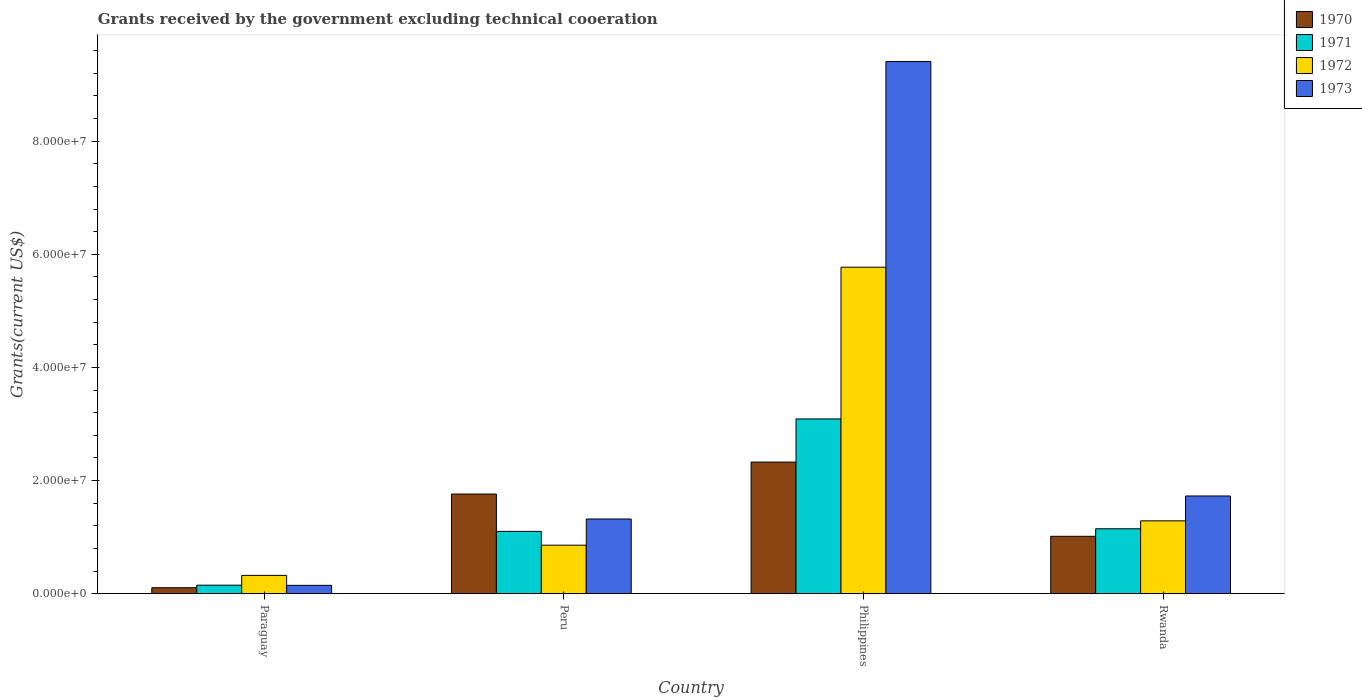Are the number of bars per tick equal to the number of legend labels?
Provide a short and direct response. Yes. How many bars are there on the 2nd tick from the left?
Provide a short and direct response. 4. How many bars are there on the 2nd tick from the right?
Make the answer very short. 4. What is the label of the 3rd group of bars from the left?
Your answer should be very brief. Philippines. In how many cases, is the number of bars for a given country not equal to the number of legend labels?
Provide a succinct answer. 0. What is the total grants received by the government in 1973 in Peru?
Give a very brief answer. 1.32e+07. Across all countries, what is the maximum total grants received by the government in 1972?
Offer a very short reply. 5.77e+07. Across all countries, what is the minimum total grants received by the government in 1973?
Offer a very short reply. 1.47e+06. In which country was the total grants received by the government in 1971 minimum?
Give a very brief answer. Paraguay. What is the total total grants received by the government in 1973 in the graph?
Make the answer very short. 1.26e+08. What is the difference between the total grants received by the government in 1972 in Paraguay and that in Philippines?
Your answer should be very brief. -5.45e+07. What is the difference between the total grants received by the government in 1973 in Philippines and the total grants received by the government in 1971 in Paraguay?
Your response must be concise. 9.26e+07. What is the average total grants received by the government in 1972 per country?
Offer a terse response. 2.06e+07. What is the difference between the total grants received by the government of/in 1973 and total grants received by the government of/in 1972 in Peru?
Your response must be concise. 4.63e+06. What is the ratio of the total grants received by the government in 1973 in Paraguay to that in Peru?
Make the answer very short. 0.11. Is the difference between the total grants received by the government in 1973 in Philippines and Rwanda greater than the difference between the total grants received by the government in 1972 in Philippines and Rwanda?
Make the answer very short. Yes. What is the difference between the highest and the second highest total grants received by the government in 1970?
Provide a short and direct response. 5.65e+06. What is the difference between the highest and the lowest total grants received by the government in 1971?
Ensure brevity in your answer.  2.94e+07. What does the 2nd bar from the left in Paraguay represents?
Your answer should be very brief. 1971. Are all the bars in the graph horizontal?
Provide a succinct answer. No. How many countries are there in the graph?
Make the answer very short. 4. Does the graph contain any zero values?
Make the answer very short. No. Does the graph contain grids?
Offer a terse response. No. How many legend labels are there?
Provide a short and direct response. 4. What is the title of the graph?
Provide a succinct answer. Grants received by the government excluding technical cooeration. Does "1999" appear as one of the legend labels in the graph?
Give a very brief answer. No. What is the label or title of the X-axis?
Your answer should be compact. Country. What is the label or title of the Y-axis?
Your answer should be compact. Grants(current US$). What is the Grants(current US$) of 1970 in Paraguay?
Provide a succinct answer. 1.05e+06. What is the Grants(current US$) of 1971 in Paraguay?
Ensure brevity in your answer.  1.50e+06. What is the Grants(current US$) in 1972 in Paraguay?
Keep it short and to the point. 3.23e+06. What is the Grants(current US$) of 1973 in Paraguay?
Provide a succinct answer. 1.47e+06. What is the Grants(current US$) of 1970 in Peru?
Make the answer very short. 1.76e+07. What is the Grants(current US$) of 1971 in Peru?
Offer a terse response. 1.10e+07. What is the Grants(current US$) in 1972 in Peru?
Your answer should be compact. 8.57e+06. What is the Grants(current US$) in 1973 in Peru?
Keep it short and to the point. 1.32e+07. What is the Grants(current US$) in 1970 in Philippines?
Give a very brief answer. 2.33e+07. What is the Grants(current US$) of 1971 in Philippines?
Offer a terse response. 3.09e+07. What is the Grants(current US$) in 1972 in Philippines?
Your response must be concise. 5.77e+07. What is the Grants(current US$) of 1973 in Philippines?
Offer a terse response. 9.41e+07. What is the Grants(current US$) in 1970 in Rwanda?
Your answer should be compact. 1.01e+07. What is the Grants(current US$) in 1971 in Rwanda?
Ensure brevity in your answer.  1.15e+07. What is the Grants(current US$) of 1972 in Rwanda?
Make the answer very short. 1.29e+07. What is the Grants(current US$) in 1973 in Rwanda?
Offer a terse response. 1.73e+07. Across all countries, what is the maximum Grants(current US$) of 1970?
Provide a succinct answer. 2.33e+07. Across all countries, what is the maximum Grants(current US$) in 1971?
Keep it short and to the point. 3.09e+07. Across all countries, what is the maximum Grants(current US$) of 1972?
Keep it short and to the point. 5.77e+07. Across all countries, what is the maximum Grants(current US$) of 1973?
Ensure brevity in your answer.  9.41e+07. Across all countries, what is the minimum Grants(current US$) of 1970?
Offer a very short reply. 1.05e+06. Across all countries, what is the minimum Grants(current US$) of 1971?
Give a very brief answer. 1.50e+06. Across all countries, what is the minimum Grants(current US$) of 1972?
Give a very brief answer. 3.23e+06. Across all countries, what is the minimum Grants(current US$) in 1973?
Make the answer very short. 1.47e+06. What is the total Grants(current US$) of 1970 in the graph?
Make the answer very short. 5.21e+07. What is the total Grants(current US$) of 1971 in the graph?
Your response must be concise. 5.49e+07. What is the total Grants(current US$) of 1972 in the graph?
Ensure brevity in your answer.  8.24e+07. What is the total Grants(current US$) of 1973 in the graph?
Your answer should be very brief. 1.26e+08. What is the difference between the Grants(current US$) in 1970 in Paraguay and that in Peru?
Your answer should be very brief. -1.66e+07. What is the difference between the Grants(current US$) of 1971 in Paraguay and that in Peru?
Keep it short and to the point. -9.51e+06. What is the difference between the Grants(current US$) of 1972 in Paraguay and that in Peru?
Your answer should be very brief. -5.34e+06. What is the difference between the Grants(current US$) in 1973 in Paraguay and that in Peru?
Provide a short and direct response. -1.17e+07. What is the difference between the Grants(current US$) in 1970 in Paraguay and that in Philippines?
Your answer should be compact. -2.22e+07. What is the difference between the Grants(current US$) of 1971 in Paraguay and that in Philippines?
Your answer should be compact. -2.94e+07. What is the difference between the Grants(current US$) of 1972 in Paraguay and that in Philippines?
Offer a very short reply. -5.45e+07. What is the difference between the Grants(current US$) in 1973 in Paraguay and that in Philippines?
Make the answer very short. -9.26e+07. What is the difference between the Grants(current US$) of 1970 in Paraguay and that in Rwanda?
Keep it short and to the point. -9.09e+06. What is the difference between the Grants(current US$) in 1971 in Paraguay and that in Rwanda?
Offer a very short reply. -9.97e+06. What is the difference between the Grants(current US$) in 1972 in Paraguay and that in Rwanda?
Keep it short and to the point. -9.64e+06. What is the difference between the Grants(current US$) in 1973 in Paraguay and that in Rwanda?
Ensure brevity in your answer.  -1.58e+07. What is the difference between the Grants(current US$) in 1970 in Peru and that in Philippines?
Offer a terse response. -5.65e+06. What is the difference between the Grants(current US$) of 1971 in Peru and that in Philippines?
Keep it short and to the point. -1.99e+07. What is the difference between the Grants(current US$) of 1972 in Peru and that in Philippines?
Ensure brevity in your answer.  -4.91e+07. What is the difference between the Grants(current US$) in 1973 in Peru and that in Philippines?
Provide a succinct answer. -8.09e+07. What is the difference between the Grants(current US$) of 1970 in Peru and that in Rwanda?
Offer a very short reply. 7.47e+06. What is the difference between the Grants(current US$) of 1971 in Peru and that in Rwanda?
Offer a terse response. -4.60e+05. What is the difference between the Grants(current US$) of 1972 in Peru and that in Rwanda?
Provide a short and direct response. -4.30e+06. What is the difference between the Grants(current US$) in 1973 in Peru and that in Rwanda?
Give a very brief answer. -4.07e+06. What is the difference between the Grants(current US$) of 1970 in Philippines and that in Rwanda?
Your answer should be very brief. 1.31e+07. What is the difference between the Grants(current US$) in 1971 in Philippines and that in Rwanda?
Your answer should be very brief. 1.94e+07. What is the difference between the Grants(current US$) of 1972 in Philippines and that in Rwanda?
Give a very brief answer. 4.48e+07. What is the difference between the Grants(current US$) of 1973 in Philippines and that in Rwanda?
Offer a terse response. 7.68e+07. What is the difference between the Grants(current US$) of 1970 in Paraguay and the Grants(current US$) of 1971 in Peru?
Your answer should be very brief. -9.96e+06. What is the difference between the Grants(current US$) in 1970 in Paraguay and the Grants(current US$) in 1972 in Peru?
Your answer should be very brief. -7.52e+06. What is the difference between the Grants(current US$) of 1970 in Paraguay and the Grants(current US$) of 1973 in Peru?
Your answer should be very brief. -1.22e+07. What is the difference between the Grants(current US$) in 1971 in Paraguay and the Grants(current US$) in 1972 in Peru?
Give a very brief answer. -7.07e+06. What is the difference between the Grants(current US$) in 1971 in Paraguay and the Grants(current US$) in 1973 in Peru?
Your response must be concise. -1.17e+07. What is the difference between the Grants(current US$) in 1972 in Paraguay and the Grants(current US$) in 1973 in Peru?
Provide a short and direct response. -9.97e+06. What is the difference between the Grants(current US$) in 1970 in Paraguay and the Grants(current US$) in 1971 in Philippines?
Offer a very short reply. -2.98e+07. What is the difference between the Grants(current US$) in 1970 in Paraguay and the Grants(current US$) in 1972 in Philippines?
Your response must be concise. -5.67e+07. What is the difference between the Grants(current US$) in 1970 in Paraguay and the Grants(current US$) in 1973 in Philippines?
Your answer should be very brief. -9.30e+07. What is the difference between the Grants(current US$) in 1971 in Paraguay and the Grants(current US$) in 1972 in Philippines?
Provide a short and direct response. -5.62e+07. What is the difference between the Grants(current US$) of 1971 in Paraguay and the Grants(current US$) of 1973 in Philippines?
Give a very brief answer. -9.26e+07. What is the difference between the Grants(current US$) of 1972 in Paraguay and the Grants(current US$) of 1973 in Philippines?
Provide a short and direct response. -9.08e+07. What is the difference between the Grants(current US$) in 1970 in Paraguay and the Grants(current US$) in 1971 in Rwanda?
Provide a succinct answer. -1.04e+07. What is the difference between the Grants(current US$) in 1970 in Paraguay and the Grants(current US$) in 1972 in Rwanda?
Your response must be concise. -1.18e+07. What is the difference between the Grants(current US$) in 1970 in Paraguay and the Grants(current US$) in 1973 in Rwanda?
Offer a very short reply. -1.62e+07. What is the difference between the Grants(current US$) of 1971 in Paraguay and the Grants(current US$) of 1972 in Rwanda?
Your answer should be compact. -1.14e+07. What is the difference between the Grants(current US$) of 1971 in Paraguay and the Grants(current US$) of 1973 in Rwanda?
Your answer should be compact. -1.58e+07. What is the difference between the Grants(current US$) of 1972 in Paraguay and the Grants(current US$) of 1973 in Rwanda?
Make the answer very short. -1.40e+07. What is the difference between the Grants(current US$) of 1970 in Peru and the Grants(current US$) of 1971 in Philippines?
Keep it short and to the point. -1.33e+07. What is the difference between the Grants(current US$) in 1970 in Peru and the Grants(current US$) in 1972 in Philippines?
Your answer should be compact. -4.01e+07. What is the difference between the Grants(current US$) of 1970 in Peru and the Grants(current US$) of 1973 in Philippines?
Offer a terse response. -7.65e+07. What is the difference between the Grants(current US$) of 1971 in Peru and the Grants(current US$) of 1972 in Philippines?
Provide a succinct answer. -4.67e+07. What is the difference between the Grants(current US$) in 1971 in Peru and the Grants(current US$) in 1973 in Philippines?
Your answer should be compact. -8.31e+07. What is the difference between the Grants(current US$) in 1972 in Peru and the Grants(current US$) in 1973 in Philippines?
Keep it short and to the point. -8.55e+07. What is the difference between the Grants(current US$) in 1970 in Peru and the Grants(current US$) in 1971 in Rwanda?
Your answer should be very brief. 6.14e+06. What is the difference between the Grants(current US$) in 1970 in Peru and the Grants(current US$) in 1972 in Rwanda?
Offer a very short reply. 4.74e+06. What is the difference between the Grants(current US$) in 1971 in Peru and the Grants(current US$) in 1972 in Rwanda?
Keep it short and to the point. -1.86e+06. What is the difference between the Grants(current US$) in 1971 in Peru and the Grants(current US$) in 1973 in Rwanda?
Offer a very short reply. -6.26e+06. What is the difference between the Grants(current US$) of 1972 in Peru and the Grants(current US$) of 1973 in Rwanda?
Offer a terse response. -8.70e+06. What is the difference between the Grants(current US$) of 1970 in Philippines and the Grants(current US$) of 1971 in Rwanda?
Ensure brevity in your answer.  1.18e+07. What is the difference between the Grants(current US$) in 1970 in Philippines and the Grants(current US$) in 1972 in Rwanda?
Offer a terse response. 1.04e+07. What is the difference between the Grants(current US$) in 1970 in Philippines and the Grants(current US$) in 1973 in Rwanda?
Offer a very short reply. 5.99e+06. What is the difference between the Grants(current US$) of 1971 in Philippines and the Grants(current US$) of 1972 in Rwanda?
Your answer should be compact. 1.80e+07. What is the difference between the Grants(current US$) in 1971 in Philippines and the Grants(current US$) in 1973 in Rwanda?
Give a very brief answer. 1.36e+07. What is the difference between the Grants(current US$) of 1972 in Philippines and the Grants(current US$) of 1973 in Rwanda?
Make the answer very short. 4.04e+07. What is the average Grants(current US$) of 1970 per country?
Provide a succinct answer. 1.30e+07. What is the average Grants(current US$) in 1971 per country?
Give a very brief answer. 1.37e+07. What is the average Grants(current US$) of 1972 per country?
Offer a terse response. 2.06e+07. What is the average Grants(current US$) in 1973 per country?
Keep it short and to the point. 3.15e+07. What is the difference between the Grants(current US$) in 1970 and Grants(current US$) in 1971 in Paraguay?
Provide a succinct answer. -4.50e+05. What is the difference between the Grants(current US$) in 1970 and Grants(current US$) in 1972 in Paraguay?
Give a very brief answer. -2.18e+06. What is the difference between the Grants(current US$) in 1970 and Grants(current US$) in 1973 in Paraguay?
Provide a succinct answer. -4.20e+05. What is the difference between the Grants(current US$) in 1971 and Grants(current US$) in 1972 in Paraguay?
Make the answer very short. -1.73e+06. What is the difference between the Grants(current US$) in 1972 and Grants(current US$) in 1973 in Paraguay?
Give a very brief answer. 1.76e+06. What is the difference between the Grants(current US$) of 1970 and Grants(current US$) of 1971 in Peru?
Your answer should be very brief. 6.60e+06. What is the difference between the Grants(current US$) in 1970 and Grants(current US$) in 1972 in Peru?
Offer a very short reply. 9.04e+06. What is the difference between the Grants(current US$) of 1970 and Grants(current US$) of 1973 in Peru?
Offer a terse response. 4.41e+06. What is the difference between the Grants(current US$) of 1971 and Grants(current US$) of 1972 in Peru?
Give a very brief answer. 2.44e+06. What is the difference between the Grants(current US$) in 1971 and Grants(current US$) in 1973 in Peru?
Your answer should be very brief. -2.19e+06. What is the difference between the Grants(current US$) in 1972 and Grants(current US$) in 1973 in Peru?
Give a very brief answer. -4.63e+06. What is the difference between the Grants(current US$) in 1970 and Grants(current US$) in 1971 in Philippines?
Keep it short and to the point. -7.63e+06. What is the difference between the Grants(current US$) in 1970 and Grants(current US$) in 1972 in Philippines?
Ensure brevity in your answer.  -3.44e+07. What is the difference between the Grants(current US$) of 1970 and Grants(current US$) of 1973 in Philippines?
Offer a very short reply. -7.08e+07. What is the difference between the Grants(current US$) in 1971 and Grants(current US$) in 1972 in Philippines?
Give a very brief answer. -2.68e+07. What is the difference between the Grants(current US$) of 1971 and Grants(current US$) of 1973 in Philippines?
Your answer should be compact. -6.32e+07. What is the difference between the Grants(current US$) of 1972 and Grants(current US$) of 1973 in Philippines?
Provide a succinct answer. -3.64e+07. What is the difference between the Grants(current US$) of 1970 and Grants(current US$) of 1971 in Rwanda?
Your response must be concise. -1.33e+06. What is the difference between the Grants(current US$) in 1970 and Grants(current US$) in 1972 in Rwanda?
Provide a short and direct response. -2.73e+06. What is the difference between the Grants(current US$) of 1970 and Grants(current US$) of 1973 in Rwanda?
Your response must be concise. -7.13e+06. What is the difference between the Grants(current US$) of 1971 and Grants(current US$) of 1972 in Rwanda?
Your answer should be very brief. -1.40e+06. What is the difference between the Grants(current US$) in 1971 and Grants(current US$) in 1973 in Rwanda?
Make the answer very short. -5.80e+06. What is the difference between the Grants(current US$) of 1972 and Grants(current US$) of 1973 in Rwanda?
Give a very brief answer. -4.40e+06. What is the ratio of the Grants(current US$) of 1970 in Paraguay to that in Peru?
Provide a short and direct response. 0.06. What is the ratio of the Grants(current US$) of 1971 in Paraguay to that in Peru?
Provide a succinct answer. 0.14. What is the ratio of the Grants(current US$) in 1972 in Paraguay to that in Peru?
Give a very brief answer. 0.38. What is the ratio of the Grants(current US$) in 1973 in Paraguay to that in Peru?
Give a very brief answer. 0.11. What is the ratio of the Grants(current US$) in 1970 in Paraguay to that in Philippines?
Provide a succinct answer. 0.05. What is the ratio of the Grants(current US$) of 1971 in Paraguay to that in Philippines?
Provide a succinct answer. 0.05. What is the ratio of the Grants(current US$) in 1972 in Paraguay to that in Philippines?
Offer a very short reply. 0.06. What is the ratio of the Grants(current US$) of 1973 in Paraguay to that in Philippines?
Ensure brevity in your answer.  0.02. What is the ratio of the Grants(current US$) in 1970 in Paraguay to that in Rwanda?
Ensure brevity in your answer.  0.1. What is the ratio of the Grants(current US$) in 1971 in Paraguay to that in Rwanda?
Your response must be concise. 0.13. What is the ratio of the Grants(current US$) in 1972 in Paraguay to that in Rwanda?
Offer a very short reply. 0.25. What is the ratio of the Grants(current US$) in 1973 in Paraguay to that in Rwanda?
Provide a short and direct response. 0.09. What is the ratio of the Grants(current US$) of 1970 in Peru to that in Philippines?
Your answer should be very brief. 0.76. What is the ratio of the Grants(current US$) in 1971 in Peru to that in Philippines?
Your answer should be very brief. 0.36. What is the ratio of the Grants(current US$) in 1972 in Peru to that in Philippines?
Provide a succinct answer. 0.15. What is the ratio of the Grants(current US$) of 1973 in Peru to that in Philippines?
Your response must be concise. 0.14. What is the ratio of the Grants(current US$) in 1970 in Peru to that in Rwanda?
Keep it short and to the point. 1.74. What is the ratio of the Grants(current US$) of 1971 in Peru to that in Rwanda?
Give a very brief answer. 0.96. What is the ratio of the Grants(current US$) in 1972 in Peru to that in Rwanda?
Give a very brief answer. 0.67. What is the ratio of the Grants(current US$) of 1973 in Peru to that in Rwanda?
Make the answer very short. 0.76. What is the ratio of the Grants(current US$) of 1970 in Philippines to that in Rwanda?
Your response must be concise. 2.29. What is the ratio of the Grants(current US$) in 1971 in Philippines to that in Rwanda?
Make the answer very short. 2.69. What is the ratio of the Grants(current US$) of 1972 in Philippines to that in Rwanda?
Keep it short and to the point. 4.48. What is the ratio of the Grants(current US$) in 1973 in Philippines to that in Rwanda?
Ensure brevity in your answer.  5.45. What is the difference between the highest and the second highest Grants(current US$) in 1970?
Your answer should be compact. 5.65e+06. What is the difference between the highest and the second highest Grants(current US$) in 1971?
Provide a succinct answer. 1.94e+07. What is the difference between the highest and the second highest Grants(current US$) in 1972?
Your answer should be very brief. 4.48e+07. What is the difference between the highest and the second highest Grants(current US$) of 1973?
Ensure brevity in your answer.  7.68e+07. What is the difference between the highest and the lowest Grants(current US$) in 1970?
Offer a terse response. 2.22e+07. What is the difference between the highest and the lowest Grants(current US$) of 1971?
Your answer should be compact. 2.94e+07. What is the difference between the highest and the lowest Grants(current US$) in 1972?
Give a very brief answer. 5.45e+07. What is the difference between the highest and the lowest Grants(current US$) of 1973?
Provide a succinct answer. 9.26e+07. 